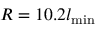<formula> <loc_0><loc_0><loc_500><loc_500>R = 1 0 . 2 l _ { \min }</formula> 